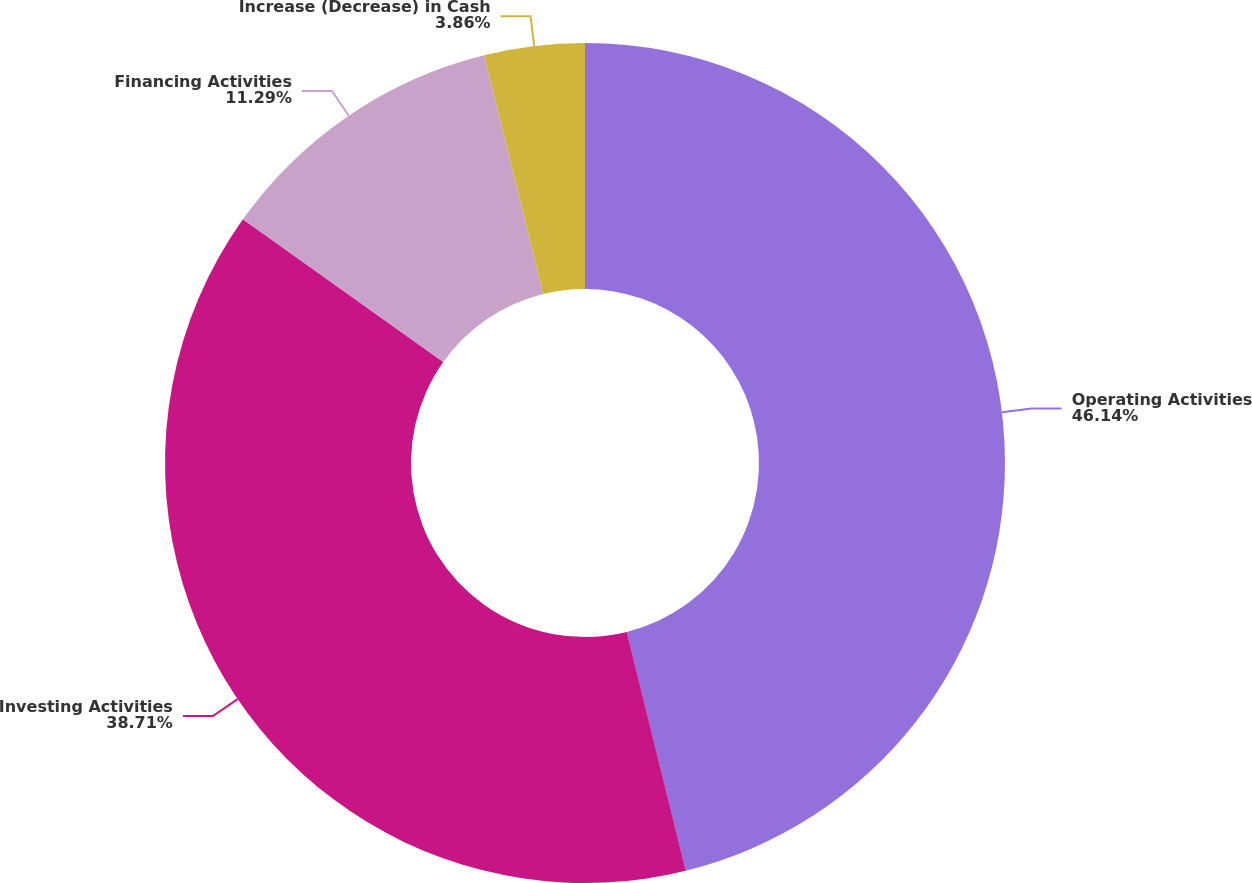<chart> <loc_0><loc_0><loc_500><loc_500><pie_chart><fcel>Operating Activities<fcel>Investing Activities<fcel>Financing Activities<fcel>Increase (Decrease) in Cash<nl><fcel>46.14%<fcel>38.71%<fcel>11.29%<fcel>3.86%<nl></chart> 